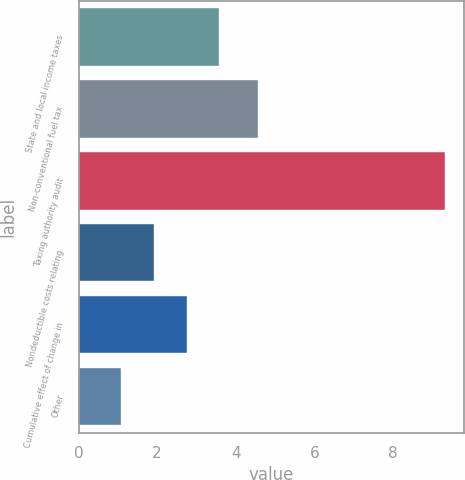Convert chart to OTSL. <chart><loc_0><loc_0><loc_500><loc_500><bar_chart><fcel>State and local income taxes<fcel>Non-conventional fuel tax<fcel>Taxing authority audit<fcel>Nondeductible costs relating<fcel>Cumulative effect of change in<fcel>Other<nl><fcel>3.58<fcel>4.57<fcel>9.34<fcel>1.92<fcel>2.75<fcel>1.09<nl></chart> 